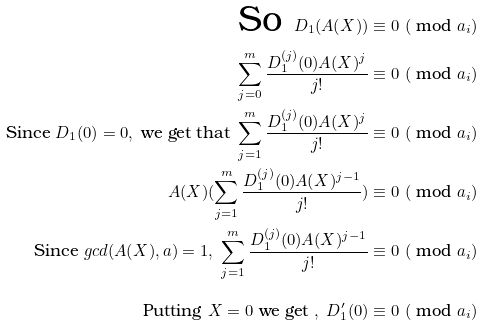<formula> <loc_0><loc_0><loc_500><loc_500>\text {So } D _ { 1 } ( A ( X ) ) & \equiv 0 \ ( \text { mod } a _ { i } ) \\ \sum _ { j = 0 } ^ { m } { \frac { D _ { 1 } ^ { ( j ) } ( 0 ) A ( X ) ^ { j } } { j ! } } & \equiv 0 \ ( \text { mod } a _ { i } ) \\ \text {Since } D _ { 1 } ( 0 ) = 0 , \text { we get that } \sum _ { j = 1 } ^ { m } { \frac { D _ { 1 } ^ { ( j ) } ( 0 ) A ( X ) ^ { j } } { j ! } } & \equiv 0 \ ( \text { mod } a _ { i } ) \\ A ( X ) ( \sum _ { j = 1 } ^ { m } { \frac { D _ { 1 } ^ { ( j ) } ( 0 ) A ( X ) ^ { j - 1 } } { j ! } } ) & \equiv 0 \ ( \text { mod } a _ { i } ) \\ \text {Since } g c d ( A ( X ) , a ) = 1 , \ \sum _ { j = 1 } ^ { m } { \frac { D _ { 1 } ^ { ( j ) } ( 0 ) A ( X ) ^ { j - 1 } } { j ! } } & \equiv 0 \ ( \text { mod } a _ { i } ) \\ \text { Putting } X = 0 \text { we get } , \ D _ { 1 } ^ { \prime } ( 0 ) & \equiv 0 \ ( \text { mod } a _ { i } )</formula> 